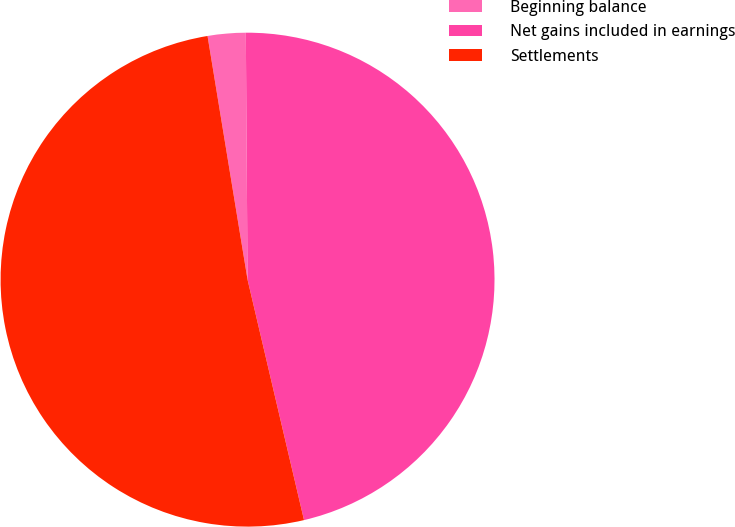Convert chart. <chart><loc_0><loc_0><loc_500><loc_500><pie_chart><fcel>Beginning balance<fcel>Net gains included in earnings<fcel>Settlements<nl><fcel>2.48%<fcel>46.44%<fcel>51.08%<nl></chart> 